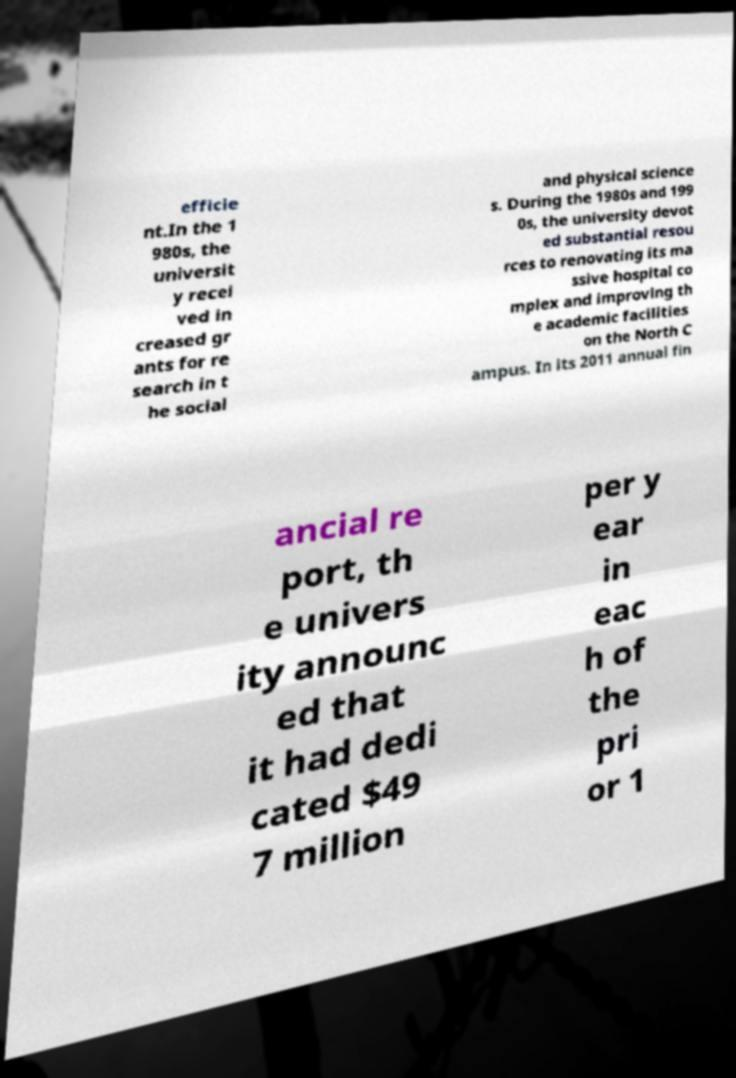Could you assist in decoding the text presented in this image and type it out clearly? efficie nt.In the 1 980s, the universit y recei ved in creased gr ants for re search in t he social and physical science s. During the 1980s and 199 0s, the university devot ed substantial resou rces to renovating its ma ssive hospital co mplex and improving th e academic facilities on the North C ampus. In its 2011 annual fin ancial re port, th e univers ity announc ed that it had dedi cated $49 7 million per y ear in eac h of the pri or 1 